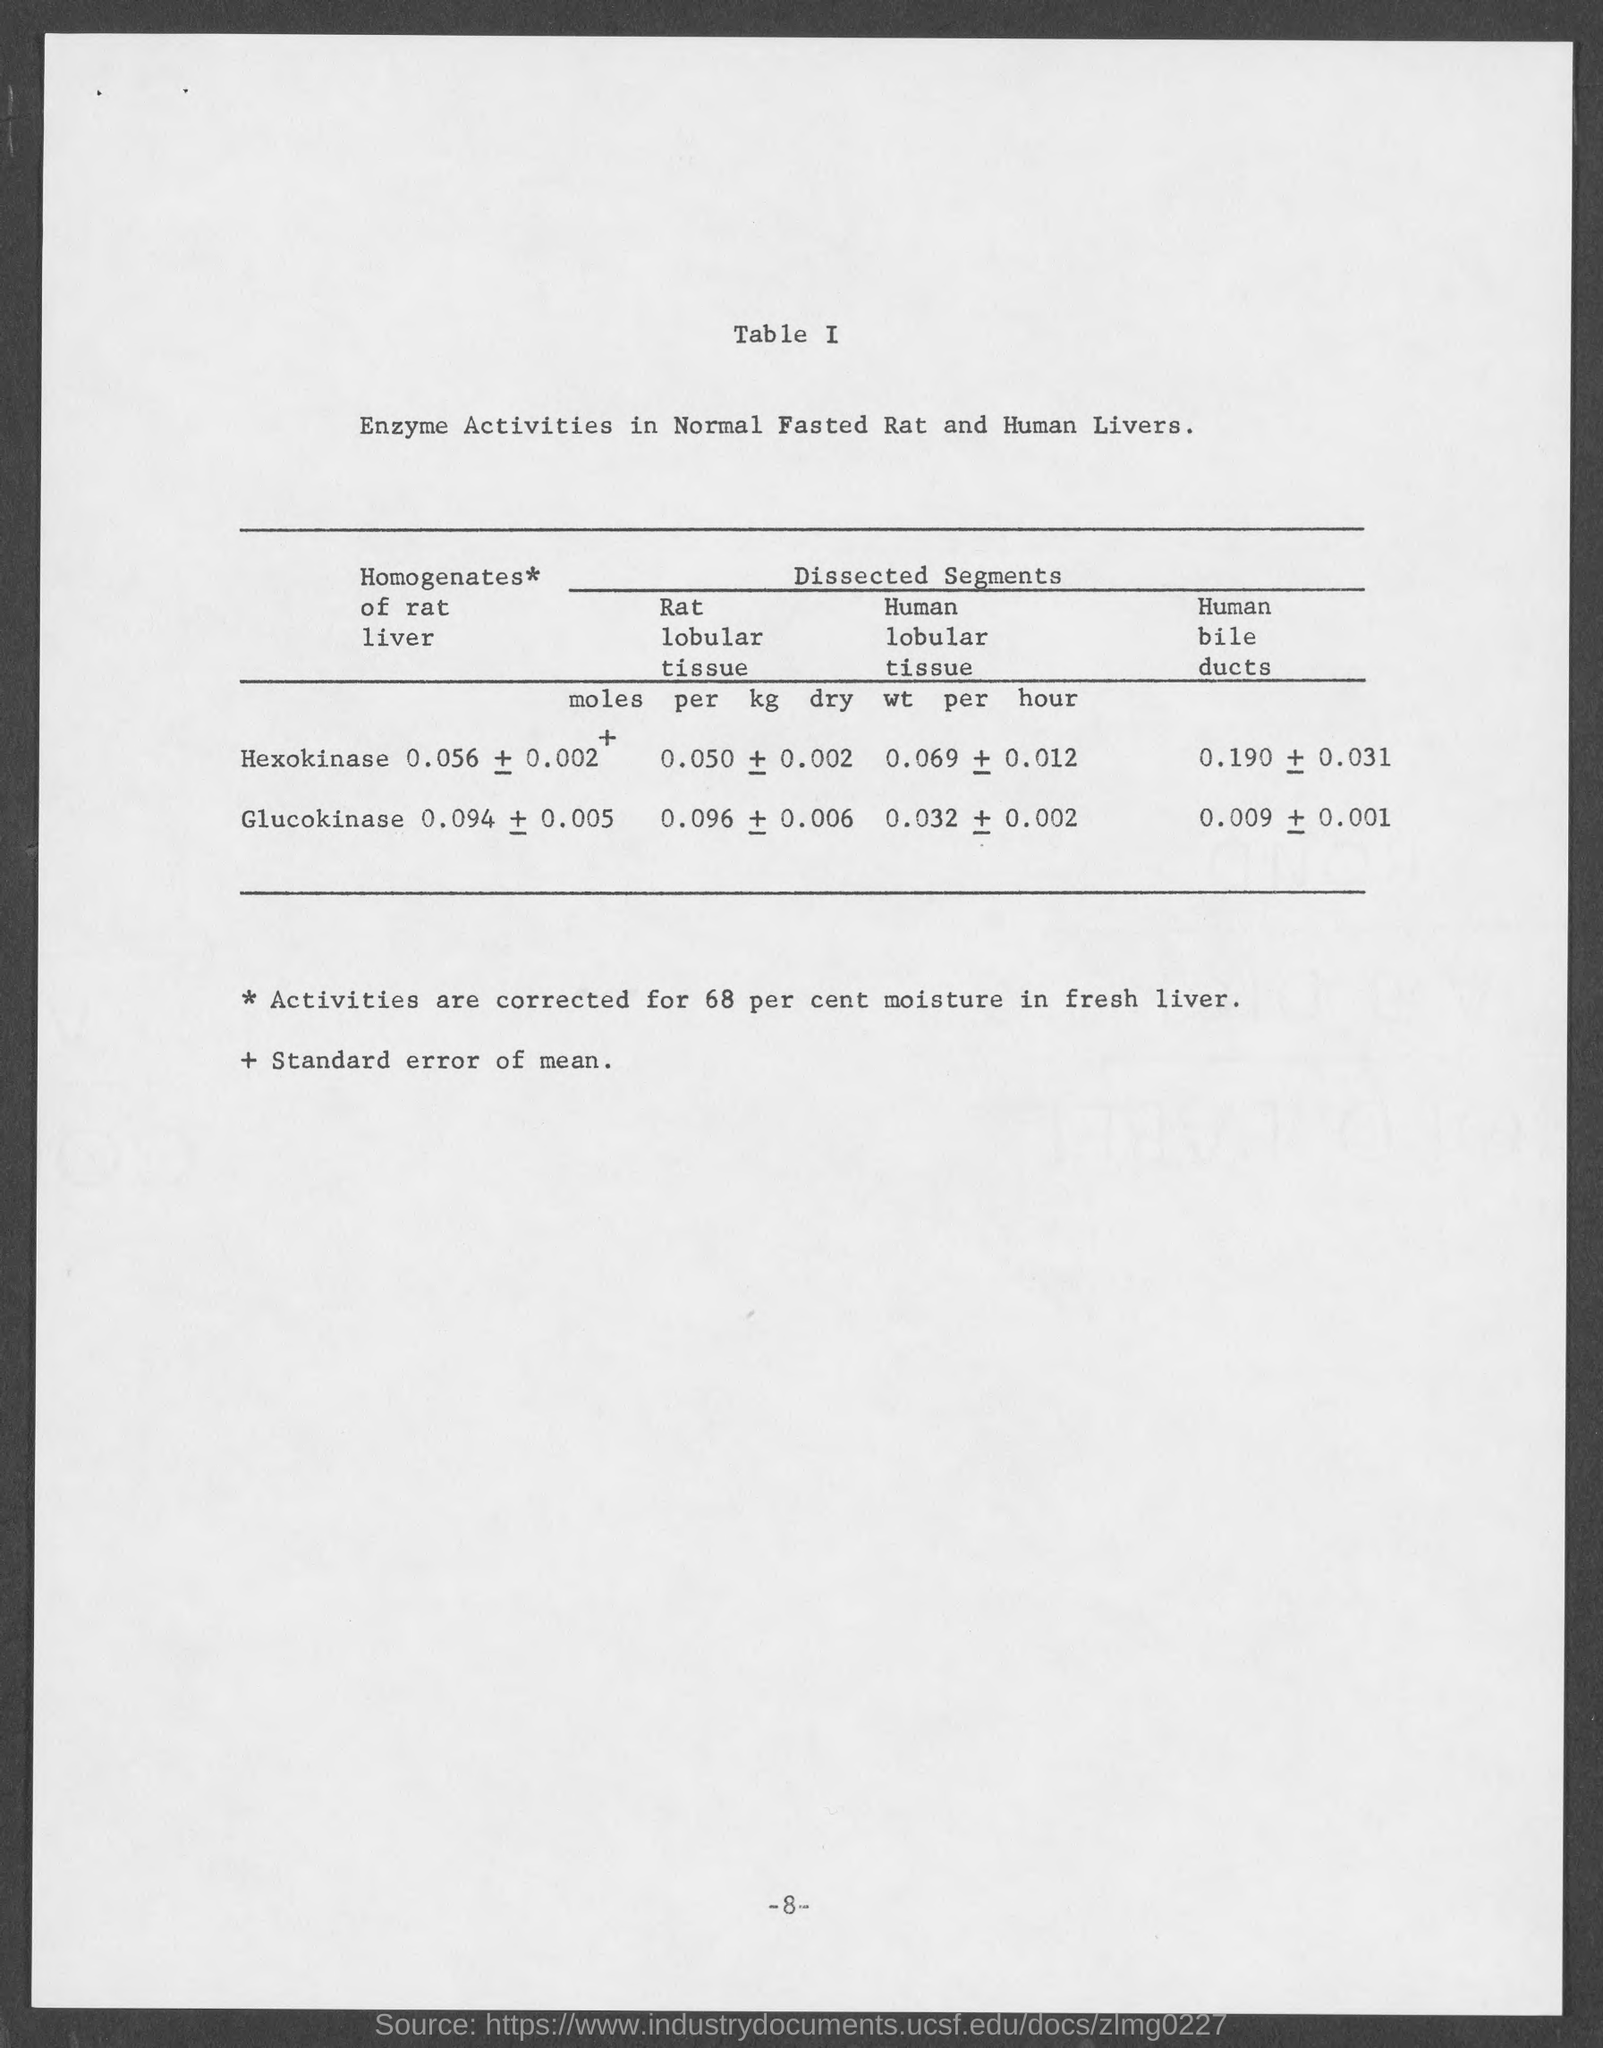Mention a couple of crucial points in this snapshot. The document describes the activities of enzymes in the livers of normal, fasted rats and humans. 